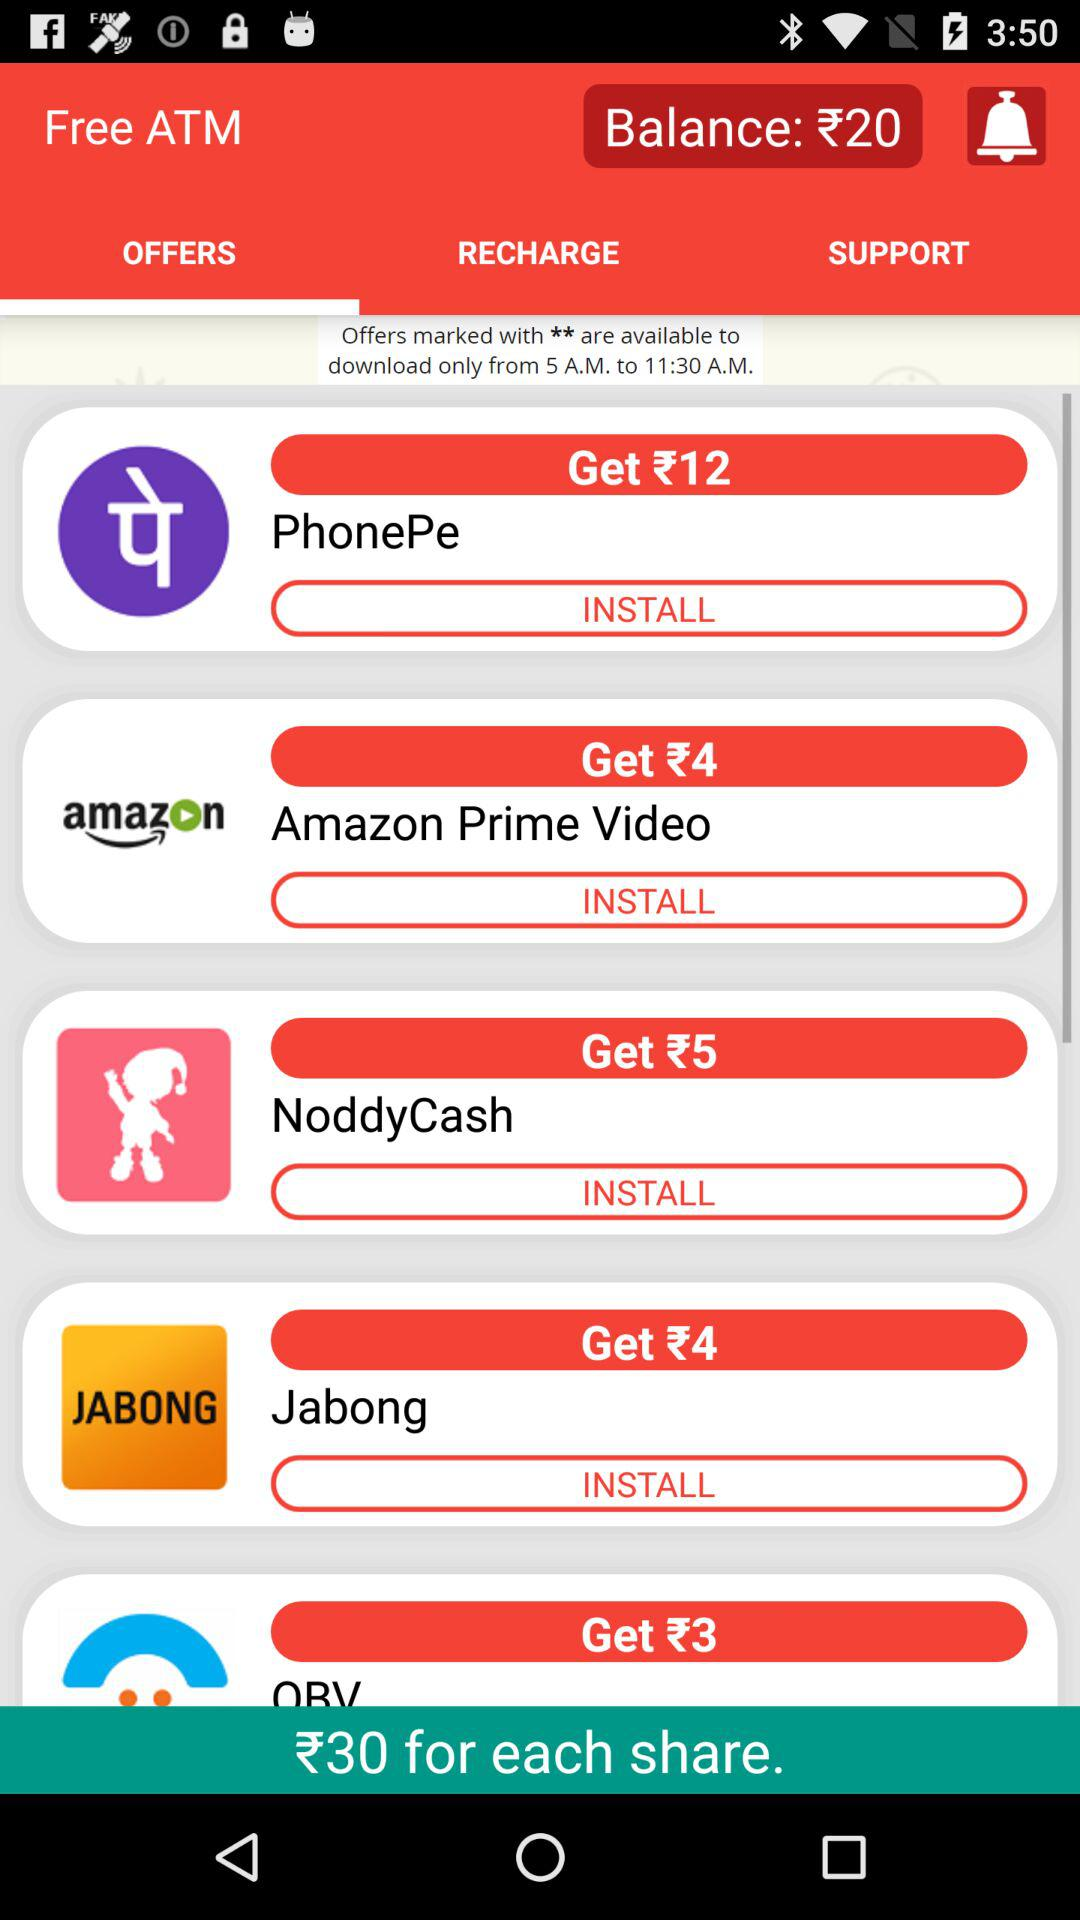How much can we earn by installing PhonePe? You can earn ₹12 by installing PhonePe. 